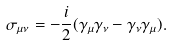<formula> <loc_0><loc_0><loc_500><loc_500>\sigma _ { \mu \nu } = - \frac { i } { 2 } ( \gamma _ { \mu } \gamma _ { \nu } - \gamma _ { \nu } \gamma _ { \mu } ) .</formula> 